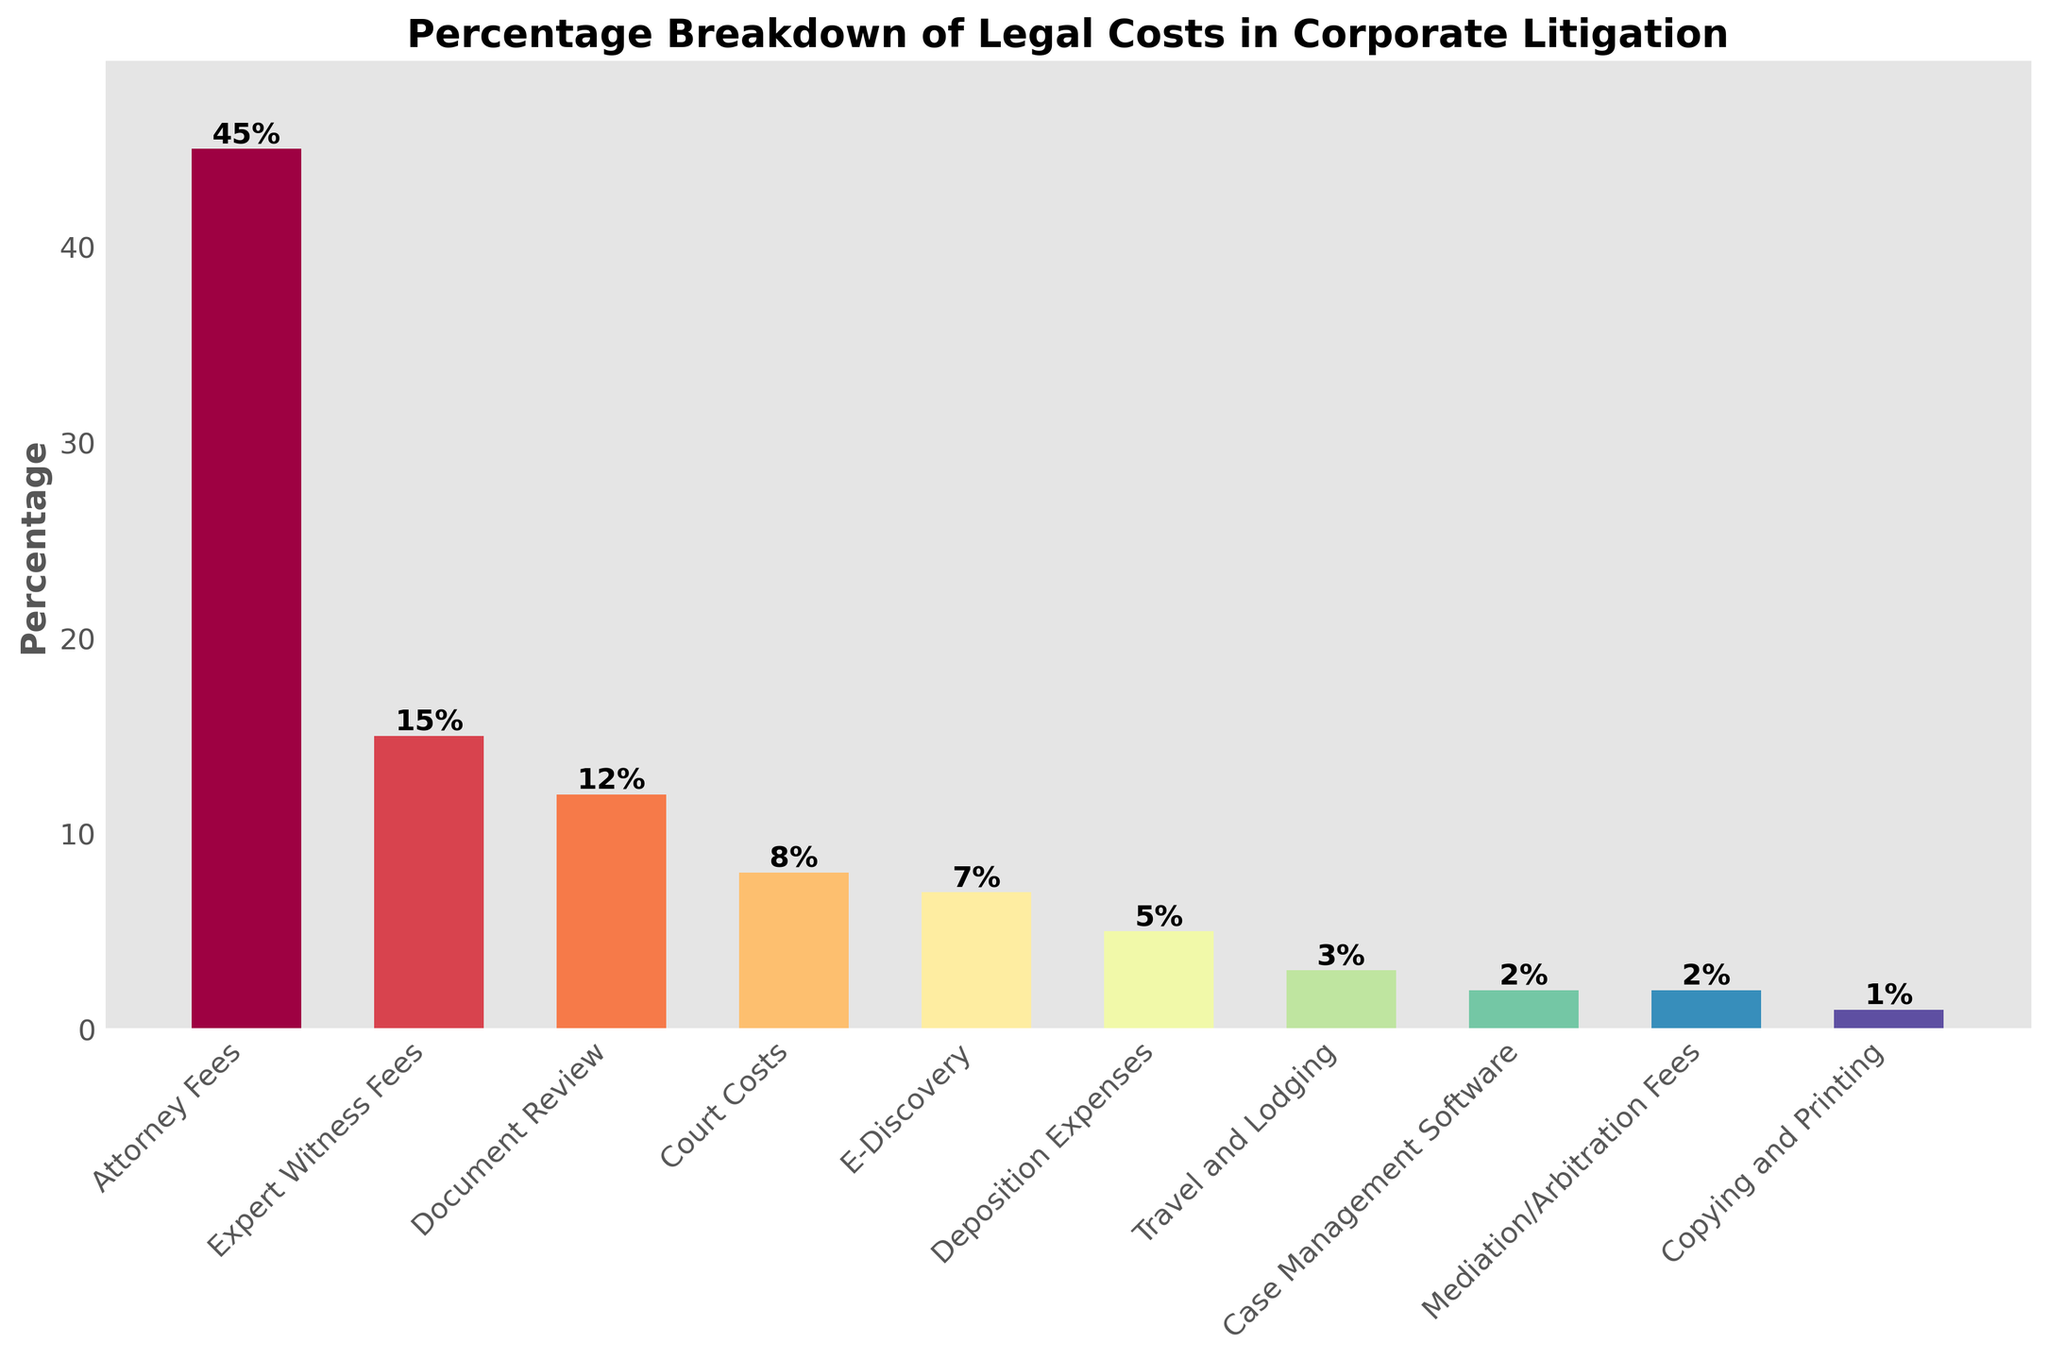What's the total percentage of costs attributed to Attorney Fees and Expert Witness Fees? To find the total percentage of costs attributed to Attorney Fees and Expert Witness Fees, we simply add the percentages of these two categories: Attorney Fees (45%) + Expert Witness Fees (15%) = 60%.
Answer: 60% Which category has the lowest percentage cost? To determine the category with the lowest percentage cost, visually inspect the bar chart and identify the shortest bar. The category with the shortest bar is "Copying and Printing" with a percentage of 1%.
Answer: Copying and Printing How much greater is the percentage cost of Attorney Fees compared to Expert Witness Fees? To find how much greater the percentage cost of Attorney Fees is compared to Expert Witness Fees, subtract the percentage of Expert Witness Fees from Attorney Fees: 45% (Attorney Fees) - 15% (Expert Witness Fees) = 30%.
Answer: 30% What's the combined percentage cost of E-Discovery, Deposition Expenses, and Travel and Lodging? To get the combined percentage cost of E-Discovery, Deposition Expenses, and Travel and Lodging, add up their percentages: E-Discovery (7%) + Deposition Expenses (5%) + Travel and Lodging (3%) = 15%.
Answer: 15% Which category has a percentage cost closest to 10%? By examining the bar chart, identify the category with a percentage value nearest to 10%. The closest category to 10% is "Document Review," which has a percentage cost of 12%.
Answer: Document Review Are the combined percentages of Court Costs, Copying and Printing, and Case Management Software greater than the percentage cost of Expert Witness Fees? First, find the combined percentage of Court Costs (8%), Copying and Printing (1%), and Case Management Software (2%): \(8% + 1% + 2% = 11%\). Then, compare this sum to the percentage cost of Expert Witness Fees (15%). Since 11% is less than 15%, the combined percentages are not greater.
Answer: No Which two categories have a combined percentage closest to that of Attorney Fees? By addition of different combinations, the categories "Document Review" (12%) and "Expert Witness Fees" (15%) together total 27%, "E-Discovery" (7%) and "Court Costs" (8%) together total 15%, and "Mediation/Arbitration Fees" (2%) and "Case Management Software" (2%) together total 4%. The closest combination is "Expert Witness Fees" (15%) and "Document Review" (12%): \(15% + 12% = 27%\).
Answer: Expert Witness Fees and Document Review How does the percentage cost for Court Costs compare to that for Deposition Expenses? To compare the percentage cost for Court Costs to Deposition Expenses, visually inspect the bar chart: Court Costs is 8% and Deposition Expenses is 5%. Thus, Court Costs is greater by 3%.
Answer: Court Costs is greater by 3% Of the categories with percentage costs below 5%, which one has the smallest cost? To determine the smallest cost in categories with less than 5%, we look at "Travel and Lodging" (3%), "Case Management Software" (2%), "Mediation/Arbitration Fees" (2%), and "Copying and Printing" (1%). The smallest percentage cost here is "Copying and Printing" with 1%.
Answer: Copying and Printing 